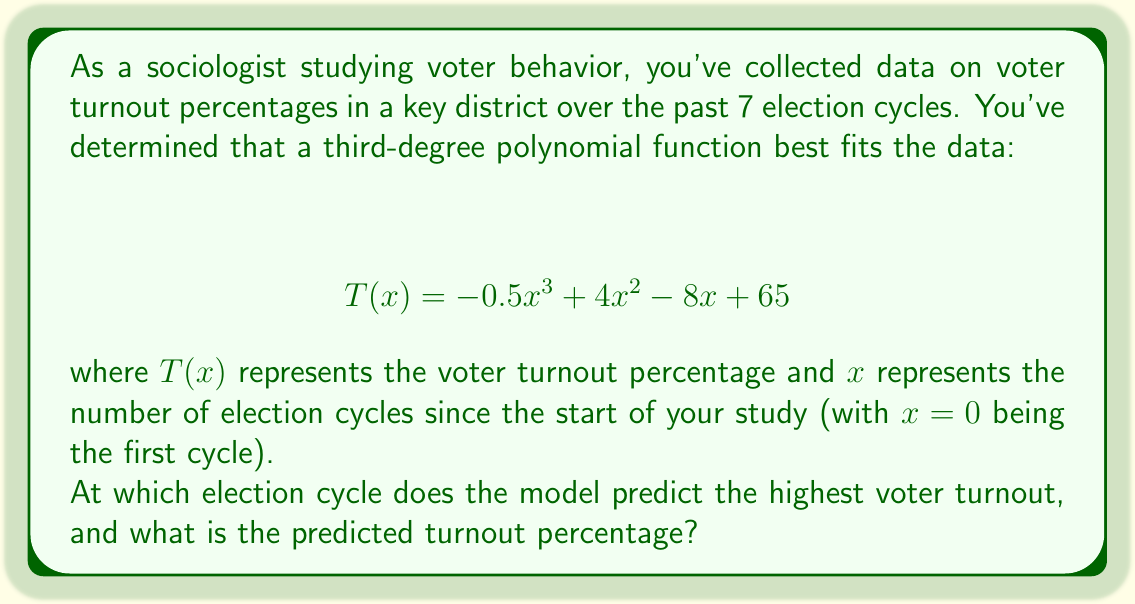What is the answer to this math problem? To find the election cycle with the highest predicted voter turnout, we need to find the maximum of the function $T(x)$. This occurs where the derivative of $T(x)$ is zero.

1) First, let's find the derivative of $T(x)$:
   $$ T'(x) = -1.5x^2 + 8x - 8 $$

2) Set $T'(x) = 0$ and solve for $x$:
   $$ -1.5x^2 + 8x - 8 = 0 $$

3) This is a quadratic equation. We can solve it using the quadratic formula:
   $$ x = \frac{-b \pm \sqrt{b^2 - 4ac}}{2a} $$
   where $a = -1.5$, $b = 8$, and $c = -8$

4) Plugging in these values:
   $$ x = \frac{-8 \pm \sqrt{64 - 4(-1.5)(-8)}}{2(-1.5)} = \frac{-8 \pm \sqrt{16}}{-3} = \frac{-8 \pm 4}{-3} $$

5) This gives us two solutions:
   $$ x_1 = \frac{-8 + 4}{-3} = \frac{-4}{-3} = \frac{4}{3} \approx 1.33 $$
   $$ x_2 = \frac{-8 - 4}{-3} = \frac{-12}{-3} = 4 $$

6) Since $x$ represents election cycles, we round to the nearest whole number. The closest whole number to both solutions is 1 for $x_1$ and 4 for $x_2$.

7) To determine which one gives the maximum, we evaluate $T(x)$ at both points:
   $$ T(1) = -0.5(1)^3 + 4(1)^2 - 8(1) + 65 = 60.5 $$
   $$ T(4) = -0.5(4)^3 + 4(4)^2 - 8(4) + 65 = 73 $$

Therefore, the model predicts the highest voter turnout at the 4th election cycle with a turnout of 73%.
Answer: 4th cycle, 73% 